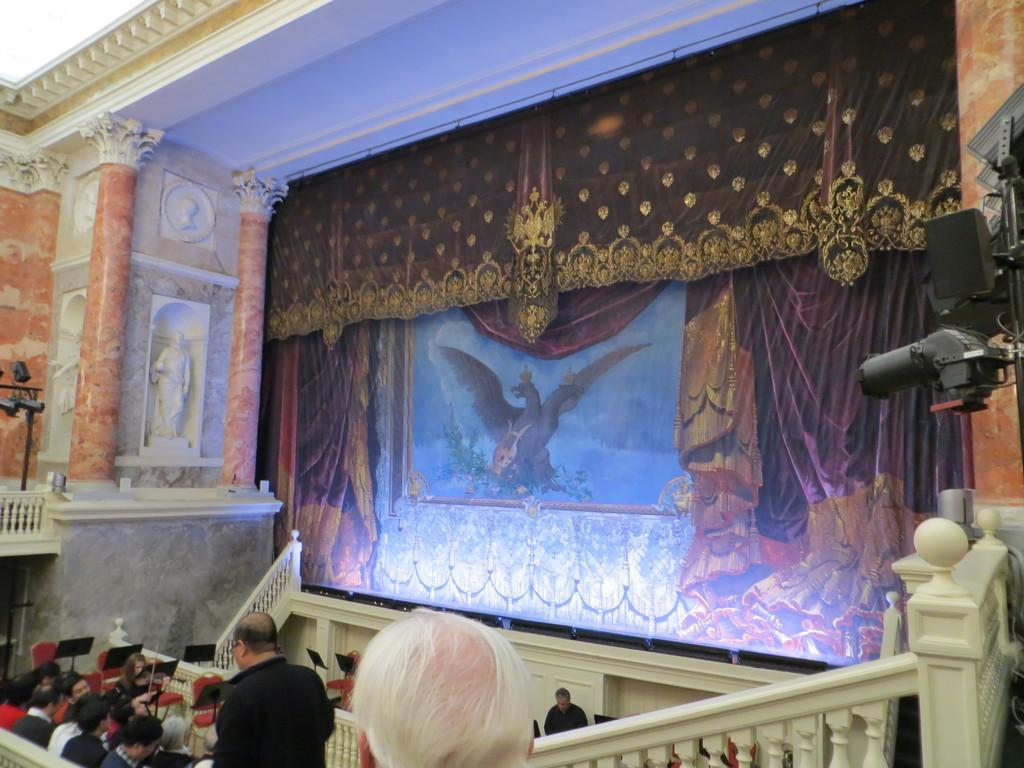Who or what is present in the image? There are people in the image. What architectural feature can be seen in the background? There are stairs in the background of the image. What type of clothing detail is visible on the people? There is art design on clothes visible in the image. What type of needle is being used to create the art design on the clothes in the image? There is no needle visible in the image, and the art design on the clothes is already present. 